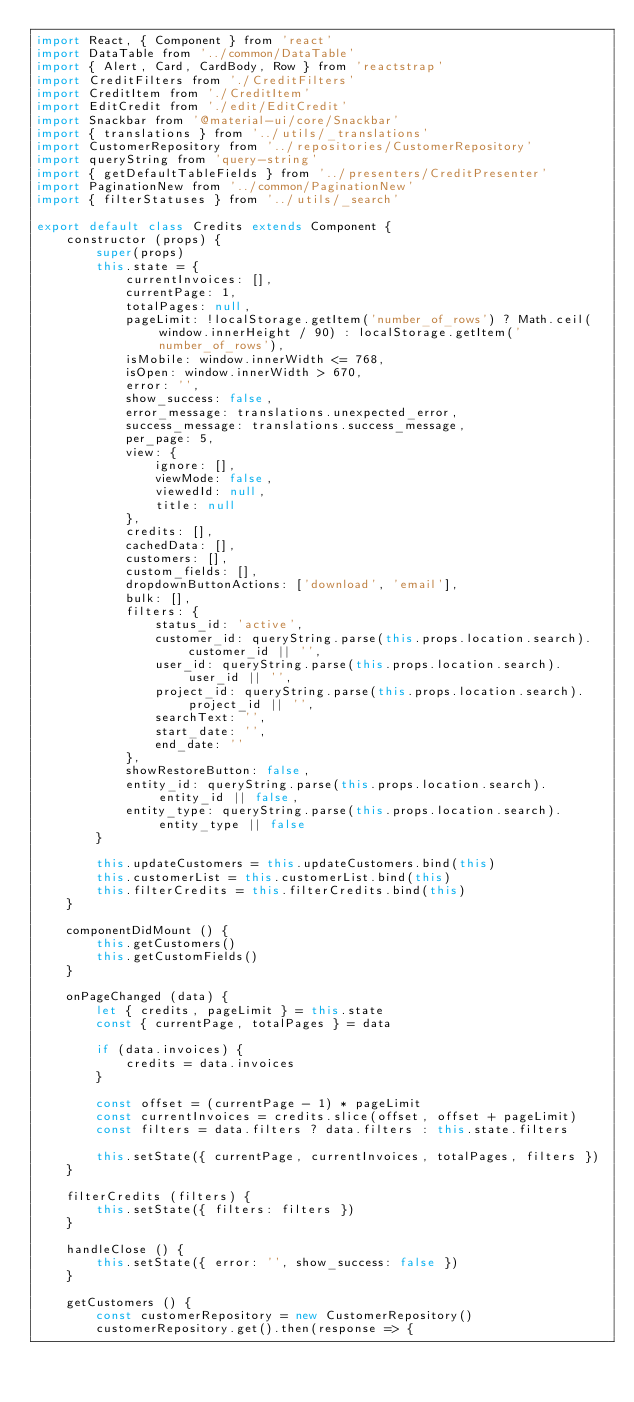Convert code to text. <code><loc_0><loc_0><loc_500><loc_500><_JavaScript_>import React, { Component } from 'react'
import DataTable from '../common/DataTable'
import { Alert, Card, CardBody, Row } from 'reactstrap'
import CreditFilters from './CreditFilters'
import CreditItem from './CreditItem'
import EditCredit from './edit/EditCredit'
import Snackbar from '@material-ui/core/Snackbar'
import { translations } from '../utils/_translations'
import CustomerRepository from '../repositories/CustomerRepository'
import queryString from 'query-string'
import { getDefaultTableFields } from '../presenters/CreditPresenter'
import PaginationNew from '../common/PaginationNew'
import { filterStatuses } from '../utils/_search'

export default class Credits extends Component {
    constructor (props) {
        super(props)
        this.state = {
            currentInvoices: [],
            currentPage: 1,
            totalPages: null,
            pageLimit: !localStorage.getItem('number_of_rows') ? Math.ceil(window.innerHeight / 90) : localStorage.getItem('number_of_rows'),
            isMobile: window.innerWidth <= 768,
            isOpen: window.innerWidth > 670,
            error: '',
            show_success: false,
            error_message: translations.unexpected_error,
            success_message: translations.success_message,
            per_page: 5,
            view: {
                ignore: [],
                viewMode: false,
                viewedId: null,
                title: null
            },
            credits: [],
            cachedData: [],
            customers: [],
            custom_fields: [],
            dropdownButtonActions: ['download', 'email'],
            bulk: [],
            filters: {
                status_id: 'active',
                customer_id: queryString.parse(this.props.location.search).customer_id || '',
                user_id: queryString.parse(this.props.location.search).user_id || '',
                project_id: queryString.parse(this.props.location.search).project_id || '',
                searchText: '',
                start_date: '',
                end_date: ''
            },
            showRestoreButton: false,
            entity_id: queryString.parse(this.props.location.search).entity_id || false,
            entity_type: queryString.parse(this.props.location.search).entity_type || false
        }

        this.updateCustomers = this.updateCustomers.bind(this)
        this.customerList = this.customerList.bind(this)
        this.filterCredits = this.filterCredits.bind(this)
    }

    componentDidMount () {
        this.getCustomers()
        this.getCustomFields()
    }

    onPageChanged (data) {
        let { credits, pageLimit } = this.state
        const { currentPage, totalPages } = data

        if (data.invoices) {
            credits = data.invoices
        }

        const offset = (currentPage - 1) * pageLimit
        const currentInvoices = credits.slice(offset, offset + pageLimit)
        const filters = data.filters ? data.filters : this.state.filters

        this.setState({ currentPage, currentInvoices, totalPages, filters })
    }

    filterCredits (filters) {
        this.setState({ filters: filters })
    }

    handleClose () {
        this.setState({ error: '', show_success: false })
    }

    getCustomers () {
        const customerRepository = new CustomerRepository()
        customerRepository.get().then(response => {</code> 